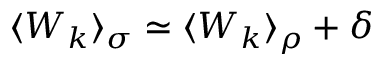<formula> <loc_0><loc_0><loc_500><loc_500>\langle W _ { k } \rangle _ { \sigma } \simeq \langle W _ { k } \rangle _ { \rho } + \delta</formula> 